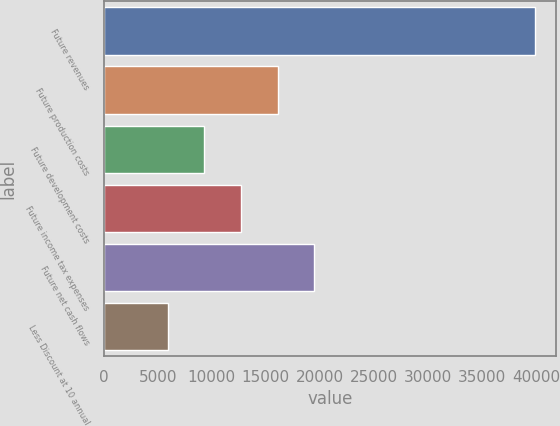Convert chart. <chart><loc_0><loc_0><loc_500><loc_500><bar_chart><fcel>Future revenues<fcel>Future production costs<fcel>Future development costs<fcel>Future income tax expenses<fcel>Future net cash flows<fcel>Less Discount at 10 annual<nl><fcel>39900<fcel>16104.2<fcel>9305.4<fcel>12704.8<fcel>19503.6<fcel>5906<nl></chart> 